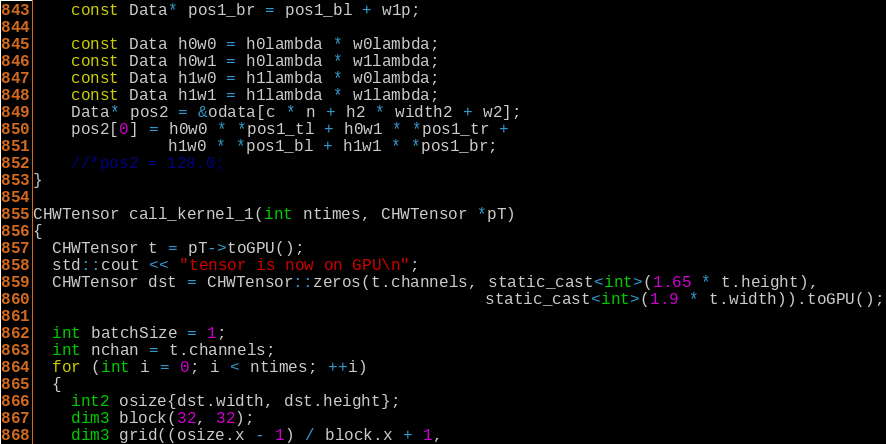Convert code to text. <code><loc_0><loc_0><loc_500><loc_500><_Cuda_>    const Data* pos1_br = pos1_bl + w1p;

    const Data h0w0 = h0lambda * w0lambda;
    const Data h0w1 = h0lambda * w1lambda;
    const Data h1w0 = h1lambda * w0lambda;
    const Data h1w1 = h1lambda * w1lambda;
    Data* pos2 = &odata[c * n + h2 * width2 + w2];
    pos2[0] = h0w0 * *pos1_tl + h0w1 * *pos1_tr +
              h1w0 * *pos1_bl + h1w1 * *pos1_br;
    //*pos2 = 128.0;
}

CHWTensor call_kernel_1(int ntimes, CHWTensor *pT)
{
  CHWTensor t = pT->toGPU();
  std::cout << "tensor is now on GPU\n";
  CHWTensor dst = CHWTensor::zeros(t.channels, static_cast<int>(1.65 * t.height),
                                               static_cast<int>(1.9 * t.width)).toGPU();
  
  int batchSize = 1;
  int nchan = t.channels;
  for (int i = 0; i < ntimes; ++i)
  {
    int2 osize{dst.width, dst.height};
    dim3 block(32, 32);
    dim3 grid((osize.x - 1) / block.x + 1,</code> 